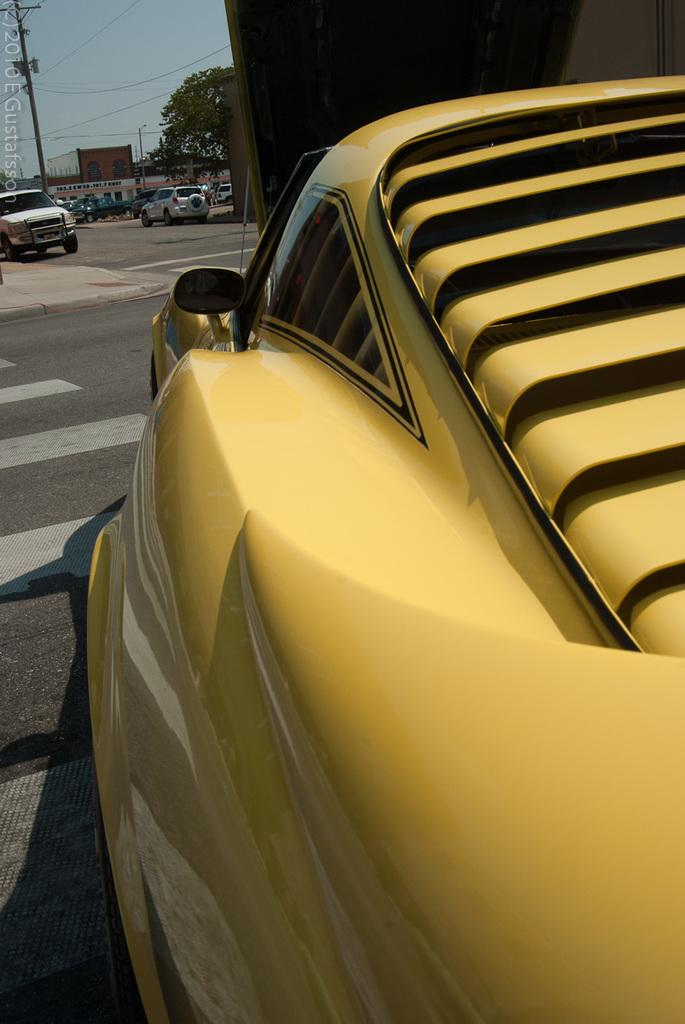What type of vehicles can be seen on the road in the image? There are cars on the road in the image. What objects are present in the image that support wires? There are poles in the image that support wires. What type of vegetation is visible in the image? There is a tree in the image. What structure can be seen in the background of the image? There is a building in the background of the image. What is visible at the top of the image? The sky is visible at the top of the image. What type of cake is being served at the event in the image? There is no event or cake present in the image; it features cars on the road, poles, wires, a tree, a building, and the sky. 